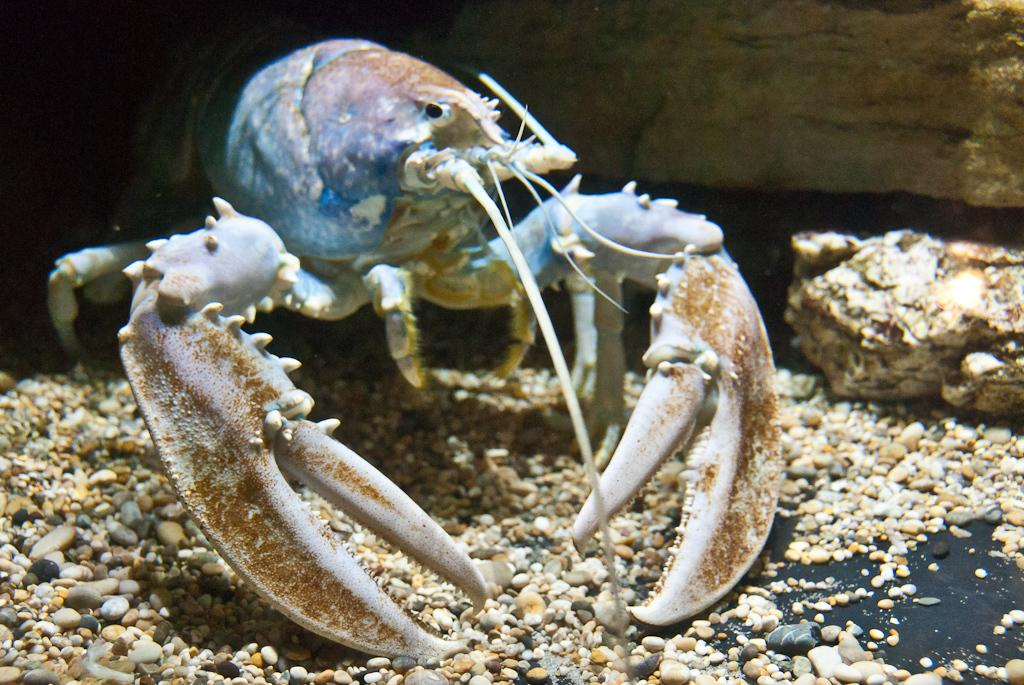What is the main subject in the center of the image? There is a lobster in the center of the image. What is the lobster resting on? The lobster is on stones. What can be seen in the background of the image? There is a wall and a rock in the background of the image. How many hands are visible in the image? There are no hands visible in the image; it features a lobster on stones with a wall and a rock in the background. What type of pigs can be seen interacting with the lobster in the image? There are no pigs present in the image; it only features a lobster on stones with a wall and a rock in the background. 